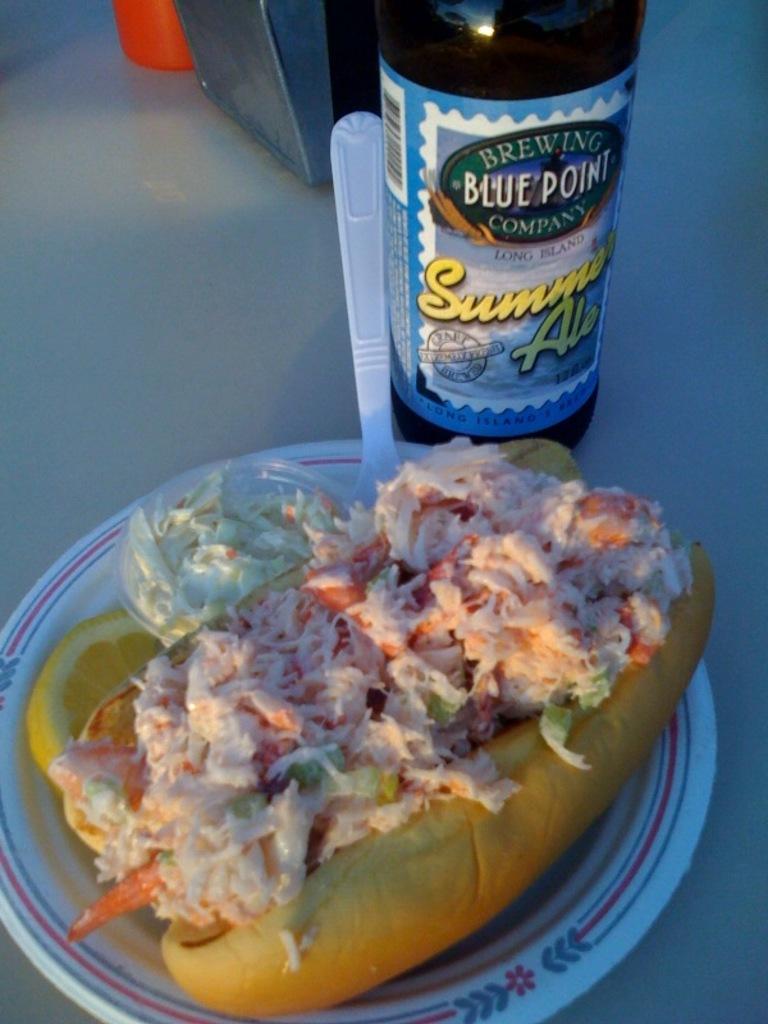What is the brand of the beverage?
Your answer should be very brief. Blue point. What is the best season to drink this beer?
Your answer should be compact. Summer. 